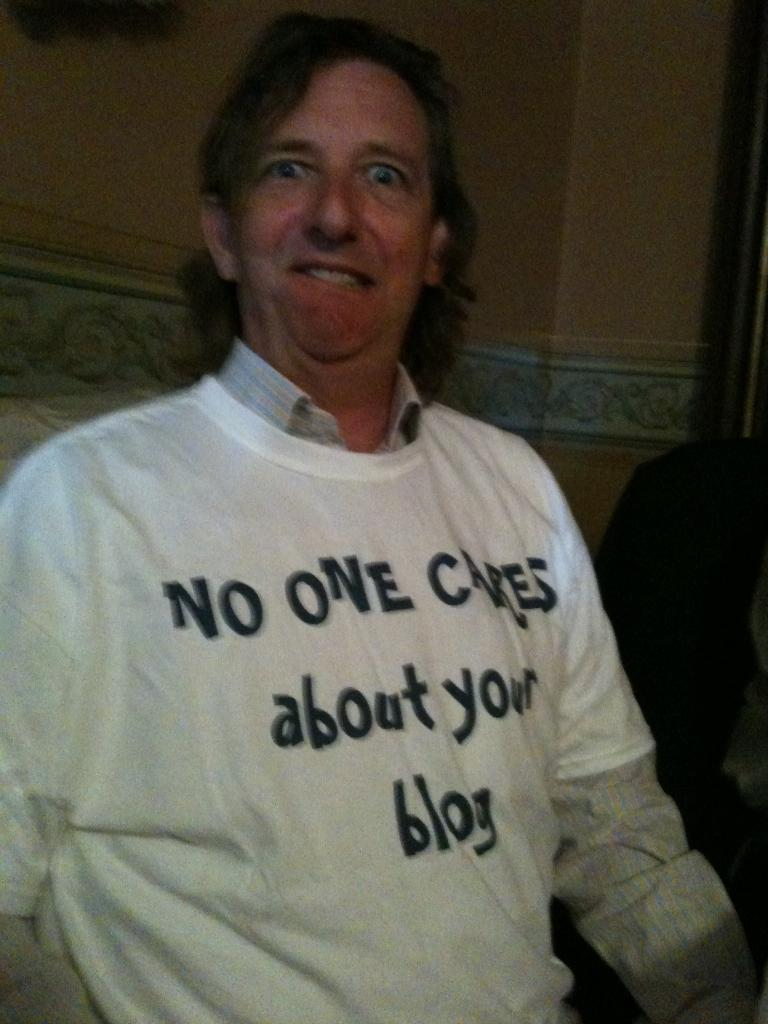Who is present in the image? There is a man in the image. What is the man wearing? The man is wearing clothes. What can be seen in the background of the image? There is a wall in the image. What is the man doing in the image? The man is giving facial expressions. Can you see a bee buzzing around the man's wrist in the image? There is no bee present in the image, and the man's wrist is not visible. 